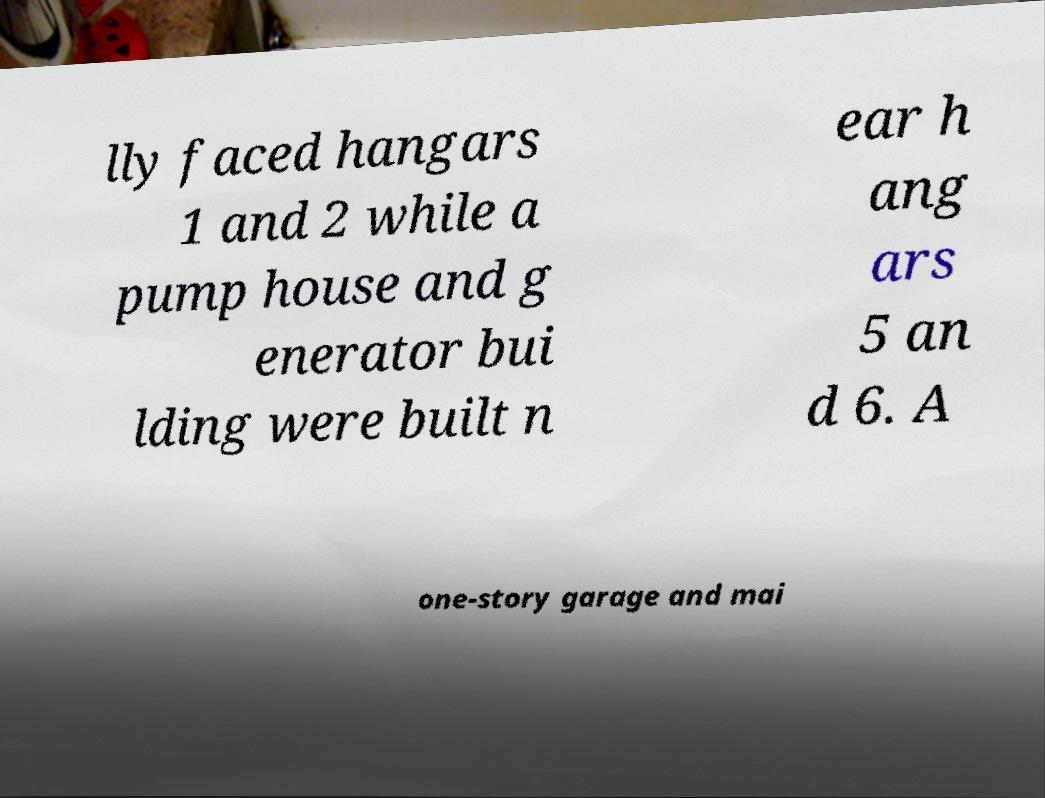What messages or text are displayed in this image? I need them in a readable, typed format. lly faced hangars 1 and 2 while a pump house and g enerator bui lding were built n ear h ang ars 5 an d 6. A one-story garage and mai 